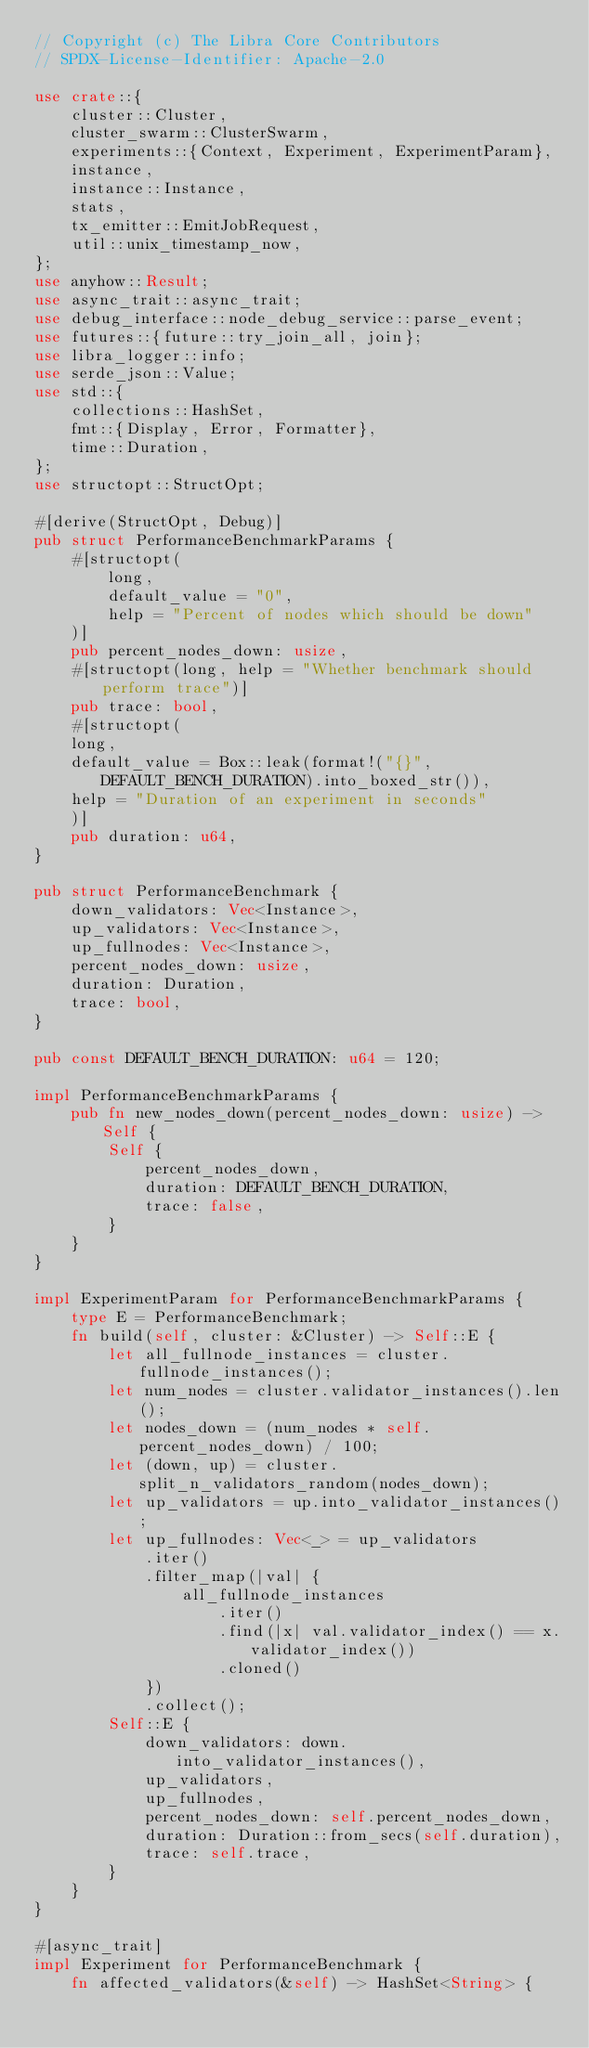<code> <loc_0><loc_0><loc_500><loc_500><_Rust_>// Copyright (c) The Libra Core Contributors
// SPDX-License-Identifier: Apache-2.0

use crate::{
    cluster::Cluster,
    cluster_swarm::ClusterSwarm,
    experiments::{Context, Experiment, ExperimentParam},
    instance,
    instance::Instance,
    stats,
    tx_emitter::EmitJobRequest,
    util::unix_timestamp_now,
};
use anyhow::Result;
use async_trait::async_trait;
use debug_interface::node_debug_service::parse_event;
use futures::{future::try_join_all, join};
use libra_logger::info;
use serde_json::Value;
use std::{
    collections::HashSet,
    fmt::{Display, Error, Formatter},
    time::Duration,
};
use structopt::StructOpt;

#[derive(StructOpt, Debug)]
pub struct PerformanceBenchmarkParams {
    #[structopt(
        long,
        default_value = "0",
        help = "Percent of nodes which should be down"
    )]
    pub percent_nodes_down: usize,
    #[structopt(long, help = "Whether benchmark should perform trace")]
    pub trace: bool,
    #[structopt(
    long,
    default_value = Box::leak(format!("{}", DEFAULT_BENCH_DURATION).into_boxed_str()),
    help = "Duration of an experiment in seconds"
    )]
    pub duration: u64,
}

pub struct PerformanceBenchmark {
    down_validators: Vec<Instance>,
    up_validators: Vec<Instance>,
    up_fullnodes: Vec<Instance>,
    percent_nodes_down: usize,
    duration: Duration,
    trace: bool,
}

pub const DEFAULT_BENCH_DURATION: u64 = 120;

impl PerformanceBenchmarkParams {
    pub fn new_nodes_down(percent_nodes_down: usize) -> Self {
        Self {
            percent_nodes_down,
            duration: DEFAULT_BENCH_DURATION,
            trace: false,
        }
    }
}

impl ExperimentParam for PerformanceBenchmarkParams {
    type E = PerformanceBenchmark;
    fn build(self, cluster: &Cluster) -> Self::E {
        let all_fullnode_instances = cluster.fullnode_instances();
        let num_nodes = cluster.validator_instances().len();
        let nodes_down = (num_nodes * self.percent_nodes_down) / 100;
        let (down, up) = cluster.split_n_validators_random(nodes_down);
        let up_validators = up.into_validator_instances();
        let up_fullnodes: Vec<_> = up_validators
            .iter()
            .filter_map(|val| {
                all_fullnode_instances
                    .iter()
                    .find(|x| val.validator_index() == x.validator_index())
                    .cloned()
            })
            .collect();
        Self::E {
            down_validators: down.into_validator_instances(),
            up_validators,
            up_fullnodes,
            percent_nodes_down: self.percent_nodes_down,
            duration: Duration::from_secs(self.duration),
            trace: self.trace,
        }
    }
}

#[async_trait]
impl Experiment for PerformanceBenchmark {
    fn affected_validators(&self) -> HashSet<String> {</code> 